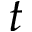Convert formula to latex. <formula><loc_0><loc_0><loc_500><loc_500>t</formula> 